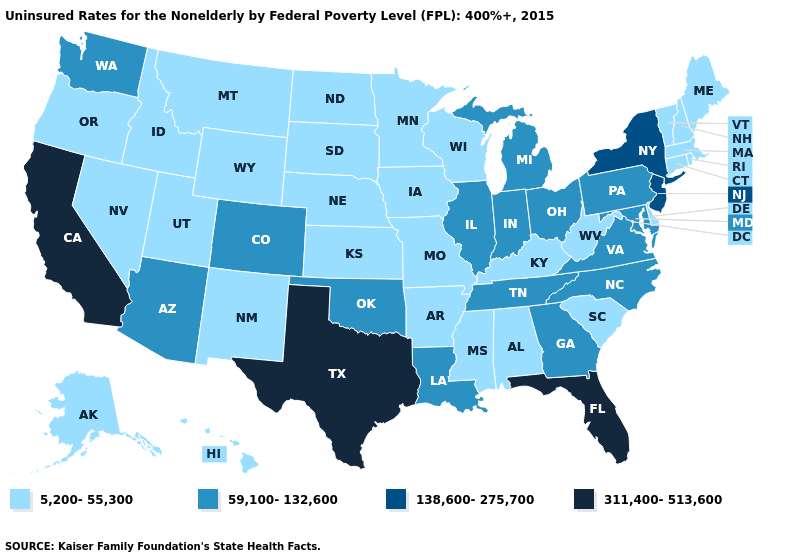What is the value of New Hampshire?
Be succinct. 5,200-55,300. Which states have the lowest value in the South?
Short answer required. Alabama, Arkansas, Delaware, Kentucky, Mississippi, South Carolina, West Virginia. Does Missouri have a lower value than Iowa?
Answer briefly. No. What is the lowest value in states that border Utah?
Keep it brief. 5,200-55,300. What is the lowest value in the USA?
Write a very short answer. 5,200-55,300. What is the value of Colorado?
Answer briefly. 59,100-132,600. What is the value of Georgia?
Keep it brief. 59,100-132,600. Does Texas have the highest value in the South?
Keep it brief. Yes. What is the value of Arizona?
Short answer required. 59,100-132,600. Which states have the lowest value in the USA?
Quick response, please. Alabama, Alaska, Arkansas, Connecticut, Delaware, Hawaii, Idaho, Iowa, Kansas, Kentucky, Maine, Massachusetts, Minnesota, Mississippi, Missouri, Montana, Nebraska, Nevada, New Hampshire, New Mexico, North Dakota, Oregon, Rhode Island, South Carolina, South Dakota, Utah, Vermont, West Virginia, Wisconsin, Wyoming. How many symbols are there in the legend?
Concise answer only. 4. Name the states that have a value in the range 311,400-513,600?
Quick response, please. California, Florida, Texas. What is the highest value in the MidWest ?
Concise answer only. 59,100-132,600. Name the states that have a value in the range 59,100-132,600?
Short answer required. Arizona, Colorado, Georgia, Illinois, Indiana, Louisiana, Maryland, Michigan, North Carolina, Ohio, Oklahoma, Pennsylvania, Tennessee, Virginia, Washington. 